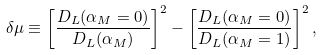Convert formula to latex. <formula><loc_0><loc_0><loc_500><loc_500>\delta \mu \equiv \left [ \frac { D _ { L } ( \alpha _ { M } = 0 ) } { D _ { L } ( \alpha _ { M } ) } \right ] ^ { 2 } - \left [ \frac { D _ { L } ( \alpha _ { M } = 0 ) } { D _ { L } ( \alpha _ { M } = 1 ) } \right ] ^ { 2 } ,</formula> 